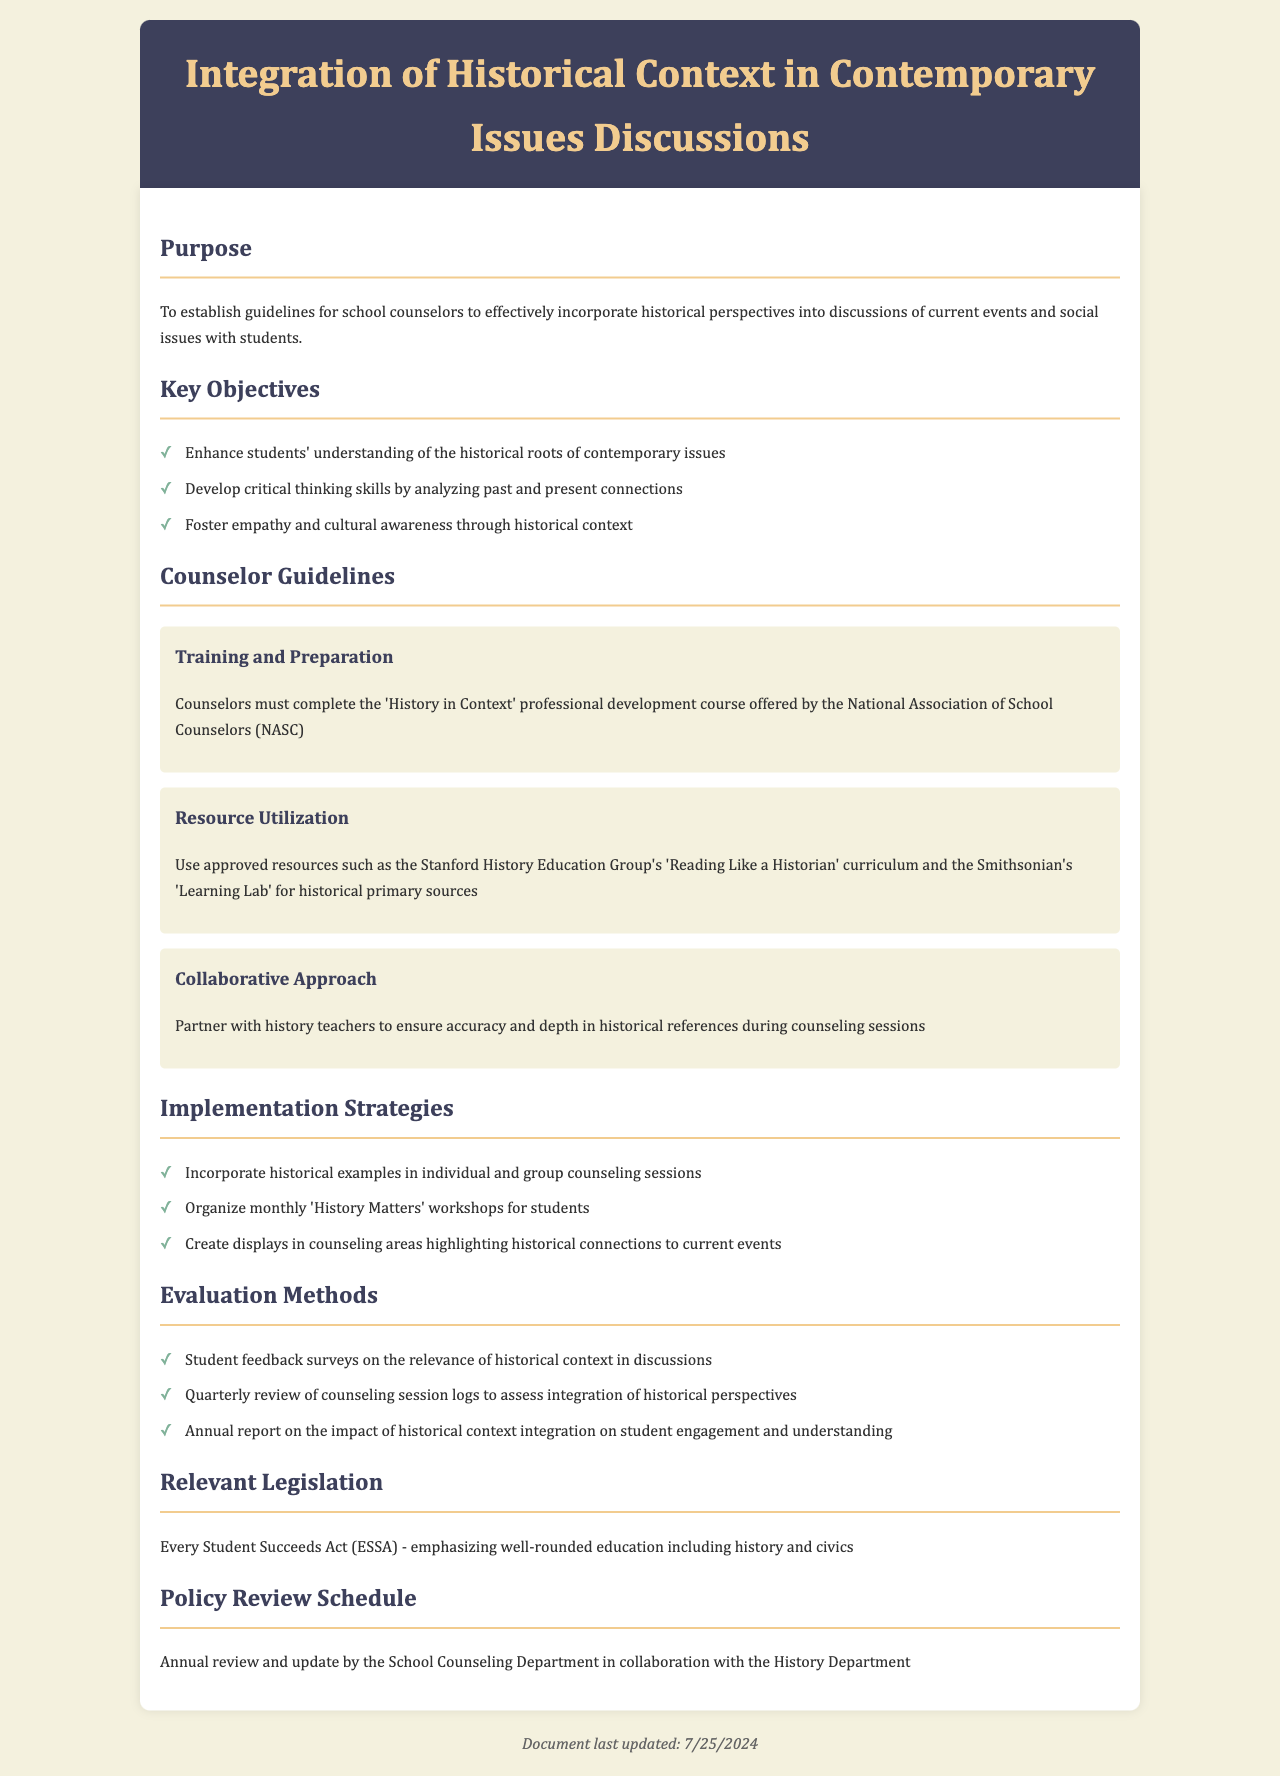What is the purpose of the document? The purpose section outlines the reason for the document, which is to establish guidelines for school counselors.
Answer: To establish guidelines for school counselors What is one key objective outlined in the document? The key objectives section lists goals for using historical contexts, one of which includes enhancing students' understanding.
Answer: Enhance students' understanding of the historical roots of contemporary issues Which professional development course must counselors complete? The training guideline specifies the name of the course required for counselors.
Answer: 'History in Context' What resources are recommended for counselors? The resource utilization guideline mentions specific approved resources for historical context discussions.
Answer: Stanford History Education Group's 'Reading Like a Historian' curriculum How frequently should the policy be reviewed? The policy review schedule indicates the frequency of updates to the document.
Answer: Annual review What method is suggested for evaluating the integration of historical context? The evaluation methods section provides a way to assess how well historical contexts are included in counseling.
Answer: Student feedback surveys on the relevance of historical context in discussions What legislation is relevant to this policy? The relevant legislation section states a specific act that underscores the importance of history in education.
Answer: Every Student Succeeds Act (ESSA) What is the title of the document? The title is the main heading at the top of the document, summarizing its focus.
Answer: Integration of Historical Context in Contemporary Issues Discussions 